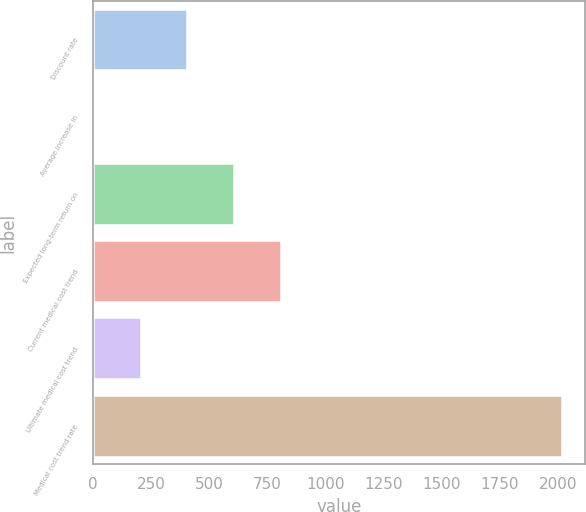<chart> <loc_0><loc_0><loc_500><loc_500><bar_chart><fcel>Discount rate<fcel>Average increase in<fcel>Expected long-term return on<fcel>Current medical cost trend<fcel>Ultimate medical cost trend<fcel>Medical cost trend rate<nl><fcel>406.4<fcel>3.5<fcel>607.85<fcel>809.3<fcel>204.95<fcel>2018<nl></chart> 